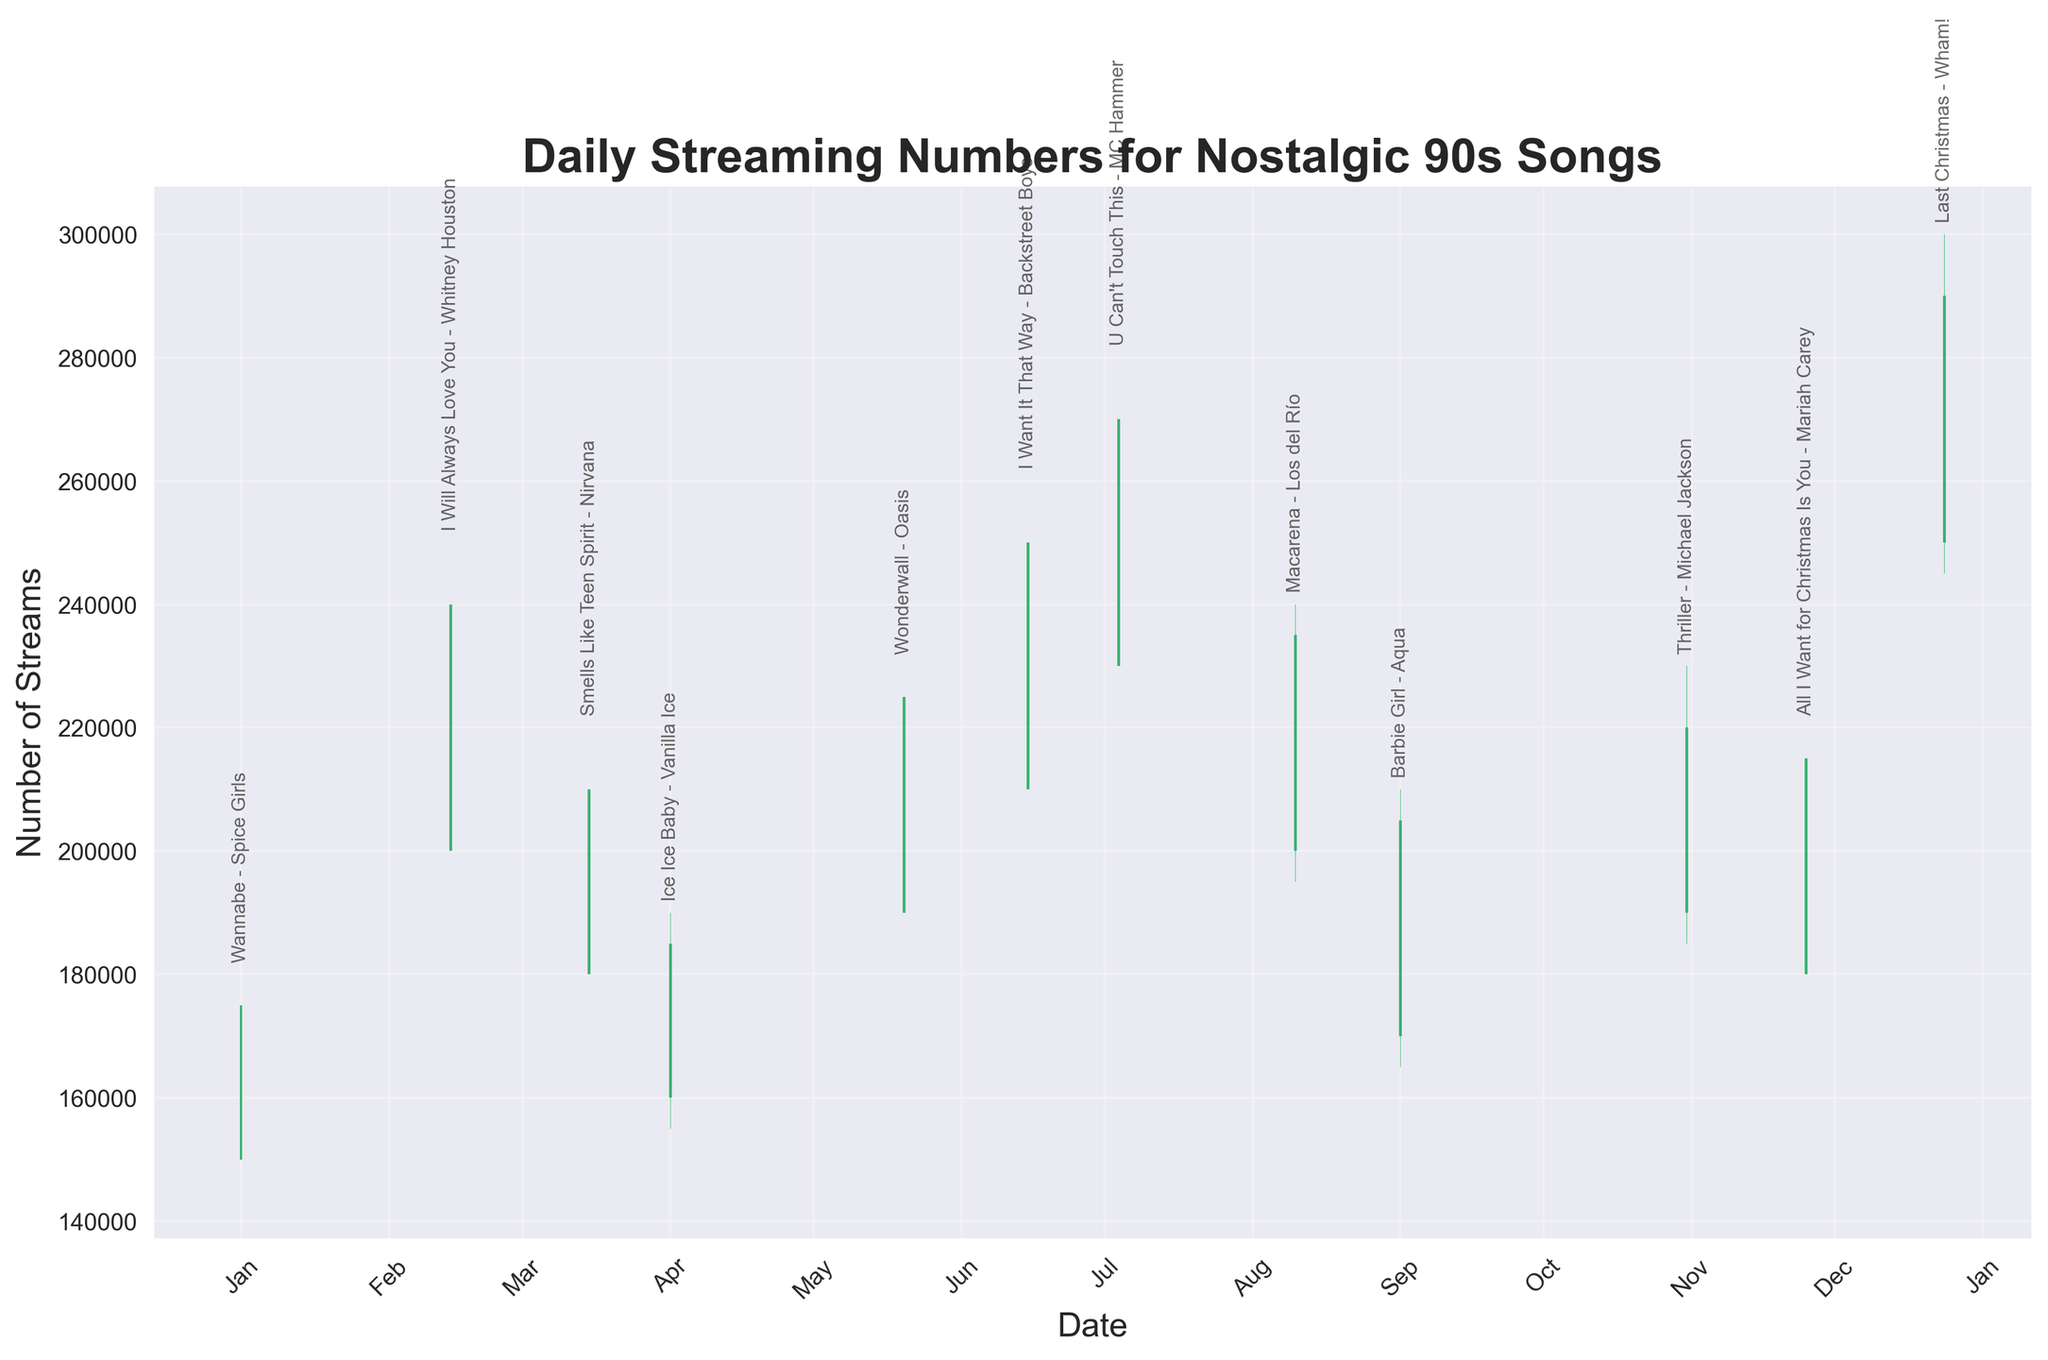What is the title of the chart? The title is displayed at the top of the chart in a bold font. It provides a brief description of what the chart represents.
Answer: Daily Streaming Numbers for Nostalgic 90s Songs What are the axes labels of the chart? The X-axis label is shown horizontally at the bottom, and the Y-axis label is shown vertically on the left side.
Answer: Date, Number of Streams Which song had the highest number of streams in a single day? The song with the highest peak (the tallest bar) on the Y-axis represents the highest number of streams.
Answer: Last Christmas - Wham! What is the color representation for the streams when they closed higher than they opened? Observe the bars that are filled in one color when the close value is higher than the open value.
Answer: Mediumseagreen What trend can you observe for "I Will Always Love You - Whitney Houston" from February 14th? Compare the open and close values to see if the streaming numbers were generally increasing or decreasing.
Answer: Increasing Which month saw the highest streaming numbers overall when examining the chart? Identify the month with the highest peaks on the chart.
Answer: December Compare the streaming numbers of "Barbie Girl - Aqua" between the open and close values. Did it close higher or lower? Look at the bar for September 1st and see if it is green (higher close) or red (lower close).
Answer: Higher What is the average closing stream count for the first three songs in the dataset? Sum the closing values for "Wannabe - Spice Girls", "I Will Always Love You - Whitney Houston", and "Smells Like Teen Spirit - Nirvana" and divide by 3.
Answer: 208,333 How many songs had a close value higher than 200,000 streams? Count the number of bars where the closing stream value is greater than 200,000.
Answer: 7 Between "Ice Ice Baby - Vanilla Ice" and "Wonderwall - Oasis", which song had a greater increase in streams from open to close? Calculate the differences between the open and close values for both songs and compare them.
Answer: Wonderwall - Oasis 